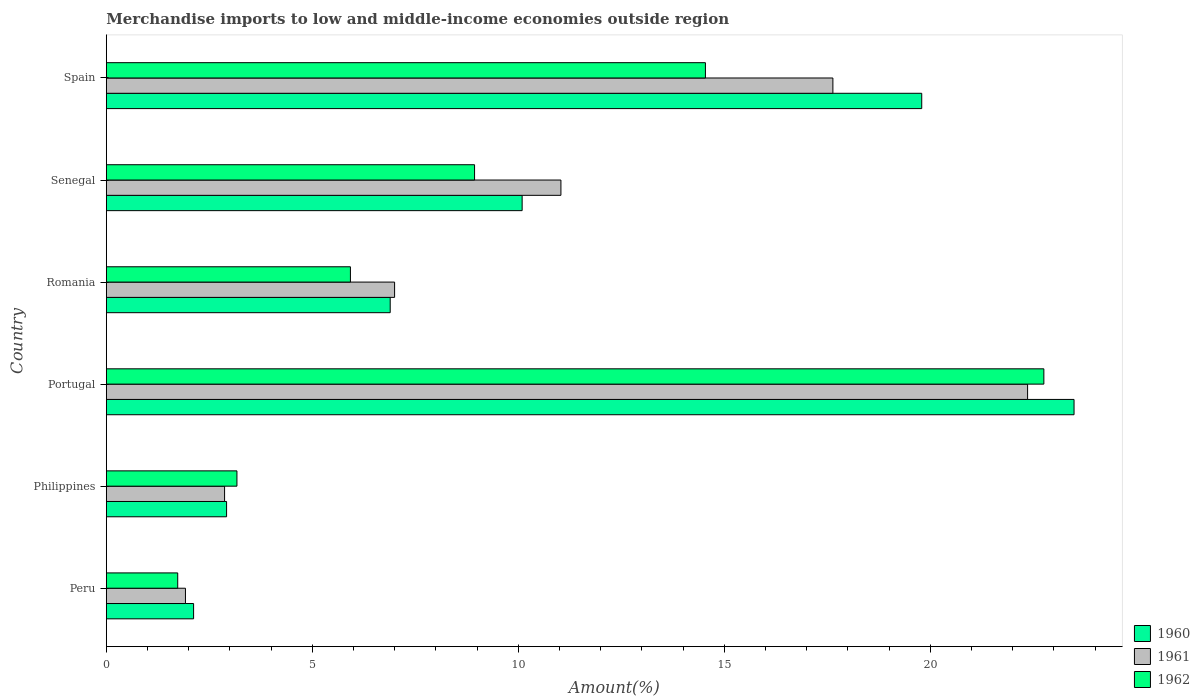How many different coloured bars are there?
Keep it short and to the point. 3. How many groups of bars are there?
Offer a terse response. 6. What is the label of the 3rd group of bars from the top?
Offer a very short reply. Romania. What is the percentage of amount earned from merchandise imports in 1960 in Senegal?
Your response must be concise. 10.09. Across all countries, what is the maximum percentage of amount earned from merchandise imports in 1962?
Provide a short and direct response. 22.76. Across all countries, what is the minimum percentage of amount earned from merchandise imports in 1962?
Offer a very short reply. 1.73. In which country was the percentage of amount earned from merchandise imports in 1960 maximum?
Your answer should be very brief. Portugal. What is the total percentage of amount earned from merchandise imports in 1960 in the graph?
Give a very brief answer. 65.3. What is the difference between the percentage of amount earned from merchandise imports in 1960 in Romania and that in Spain?
Your response must be concise. -12.9. What is the difference between the percentage of amount earned from merchandise imports in 1961 in Spain and the percentage of amount earned from merchandise imports in 1962 in Philippines?
Make the answer very short. 14.47. What is the average percentage of amount earned from merchandise imports in 1961 per country?
Ensure brevity in your answer.  10.47. What is the difference between the percentage of amount earned from merchandise imports in 1962 and percentage of amount earned from merchandise imports in 1960 in Portugal?
Offer a terse response. -0.73. In how many countries, is the percentage of amount earned from merchandise imports in 1960 greater than 16 %?
Your answer should be very brief. 2. What is the ratio of the percentage of amount earned from merchandise imports in 1962 in Peru to that in Portugal?
Provide a succinct answer. 0.08. Is the percentage of amount earned from merchandise imports in 1962 in Philippines less than that in Portugal?
Give a very brief answer. Yes. Is the difference between the percentage of amount earned from merchandise imports in 1962 in Senegal and Spain greater than the difference between the percentage of amount earned from merchandise imports in 1960 in Senegal and Spain?
Offer a terse response. Yes. What is the difference between the highest and the second highest percentage of amount earned from merchandise imports in 1962?
Provide a succinct answer. 8.21. What is the difference between the highest and the lowest percentage of amount earned from merchandise imports in 1960?
Provide a succinct answer. 21.37. Is the sum of the percentage of amount earned from merchandise imports in 1960 in Peru and Spain greater than the maximum percentage of amount earned from merchandise imports in 1962 across all countries?
Provide a short and direct response. No. What does the 1st bar from the top in Spain represents?
Keep it short and to the point. 1962. How many bars are there?
Keep it short and to the point. 18. How many countries are there in the graph?
Ensure brevity in your answer.  6. Does the graph contain any zero values?
Keep it short and to the point. No. Does the graph contain grids?
Ensure brevity in your answer.  No. How are the legend labels stacked?
Provide a succinct answer. Vertical. What is the title of the graph?
Make the answer very short. Merchandise imports to low and middle-income economies outside region. What is the label or title of the X-axis?
Provide a short and direct response. Amount(%). What is the label or title of the Y-axis?
Provide a short and direct response. Country. What is the Amount(%) of 1960 in Peru?
Offer a terse response. 2.12. What is the Amount(%) of 1961 in Peru?
Make the answer very short. 1.92. What is the Amount(%) in 1962 in Peru?
Keep it short and to the point. 1.73. What is the Amount(%) in 1960 in Philippines?
Provide a short and direct response. 2.92. What is the Amount(%) in 1961 in Philippines?
Your response must be concise. 2.87. What is the Amount(%) of 1962 in Philippines?
Provide a succinct answer. 3.17. What is the Amount(%) of 1960 in Portugal?
Offer a very short reply. 23.49. What is the Amount(%) in 1961 in Portugal?
Provide a succinct answer. 22.36. What is the Amount(%) of 1962 in Portugal?
Your answer should be very brief. 22.76. What is the Amount(%) of 1960 in Romania?
Give a very brief answer. 6.89. What is the Amount(%) in 1961 in Romania?
Your answer should be compact. 7. What is the Amount(%) of 1962 in Romania?
Your answer should be very brief. 5.92. What is the Amount(%) of 1960 in Senegal?
Provide a succinct answer. 10.09. What is the Amount(%) of 1961 in Senegal?
Your response must be concise. 11.03. What is the Amount(%) of 1962 in Senegal?
Provide a succinct answer. 8.94. What is the Amount(%) of 1960 in Spain?
Your response must be concise. 19.79. What is the Amount(%) in 1961 in Spain?
Provide a short and direct response. 17.64. What is the Amount(%) of 1962 in Spain?
Keep it short and to the point. 14.54. Across all countries, what is the maximum Amount(%) in 1960?
Ensure brevity in your answer.  23.49. Across all countries, what is the maximum Amount(%) in 1961?
Your answer should be compact. 22.36. Across all countries, what is the maximum Amount(%) in 1962?
Your response must be concise. 22.76. Across all countries, what is the minimum Amount(%) in 1960?
Give a very brief answer. 2.12. Across all countries, what is the minimum Amount(%) of 1961?
Offer a terse response. 1.92. Across all countries, what is the minimum Amount(%) of 1962?
Provide a short and direct response. 1.73. What is the total Amount(%) of 1960 in the graph?
Make the answer very short. 65.3. What is the total Amount(%) in 1961 in the graph?
Offer a very short reply. 62.82. What is the total Amount(%) in 1962 in the graph?
Your response must be concise. 57.06. What is the difference between the Amount(%) of 1960 in Peru and that in Philippines?
Offer a terse response. -0.8. What is the difference between the Amount(%) in 1961 in Peru and that in Philippines?
Your response must be concise. -0.95. What is the difference between the Amount(%) in 1962 in Peru and that in Philippines?
Offer a very short reply. -1.44. What is the difference between the Amount(%) in 1960 in Peru and that in Portugal?
Give a very brief answer. -21.37. What is the difference between the Amount(%) of 1961 in Peru and that in Portugal?
Your answer should be very brief. -20.44. What is the difference between the Amount(%) in 1962 in Peru and that in Portugal?
Give a very brief answer. -21.02. What is the difference between the Amount(%) of 1960 in Peru and that in Romania?
Keep it short and to the point. -4.77. What is the difference between the Amount(%) of 1961 in Peru and that in Romania?
Provide a succinct answer. -5.08. What is the difference between the Amount(%) in 1962 in Peru and that in Romania?
Keep it short and to the point. -4.19. What is the difference between the Amount(%) in 1960 in Peru and that in Senegal?
Keep it short and to the point. -7.97. What is the difference between the Amount(%) of 1961 in Peru and that in Senegal?
Offer a terse response. -9.11. What is the difference between the Amount(%) of 1962 in Peru and that in Senegal?
Your answer should be very brief. -7.21. What is the difference between the Amount(%) of 1960 in Peru and that in Spain?
Your response must be concise. -17.67. What is the difference between the Amount(%) of 1961 in Peru and that in Spain?
Your answer should be compact. -15.71. What is the difference between the Amount(%) in 1962 in Peru and that in Spain?
Your answer should be compact. -12.81. What is the difference between the Amount(%) in 1960 in Philippines and that in Portugal?
Provide a succinct answer. -20.57. What is the difference between the Amount(%) of 1961 in Philippines and that in Portugal?
Your answer should be very brief. -19.49. What is the difference between the Amount(%) in 1962 in Philippines and that in Portugal?
Provide a short and direct response. -19.59. What is the difference between the Amount(%) of 1960 in Philippines and that in Romania?
Give a very brief answer. -3.97. What is the difference between the Amount(%) in 1961 in Philippines and that in Romania?
Your response must be concise. -4.13. What is the difference between the Amount(%) of 1962 in Philippines and that in Romania?
Your answer should be very brief. -2.75. What is the difference between the Amount(%) in 1960 in Philippines and that in Senegal?
Offer a terse response. -7.17. What is the difference between the Amount(%) of 1961 in Philippines and that in Senegal?
Ensure brevity in your answer.  -8.16. What is the difference between the Amount(%) of 1962 in Philippines and that in Senegal?
Your answer should be very brief. -5.77. What is the difference between the Amount(%) of 1960 in Philippines and that in Spain?
Ensure brevity in your answer.  -16.87. What is the difference between the Amount(%) of 1961 in Philippines and that in Spain?
Give a very brief answer. -14.77. What is the difference between the Amount(%) in 1962 in Philippines and that in Spain?
Ensure brevity in your answer.  -11.37. What is the difference between the Amount(%) of 1960 in Portugal and that in Romania?
Your response must be concise. 16.6. What is the difference between the Amount(%) in 1961 in Portugal and that in Romania?
Offer a very short reply. 15.36. What is the difference between the Amount(%) of 1962 in Portugal and that in Romania?
Provide a succinct answer. 16.83. What is the difference between the Amount(%) of 1960 in Portugal and that in Senegal?
Your answer should be very brief. 13.4. What is the difference between the Amount(%) in 1961 in Portugal and that in Senegal?
Make the answer very short. 11.33. What is the difference between the Amount(%) in 1962 in Portugal and that in Senegal?
Your response must be concise. 13.82. What is the difference between the Amount(%) of 1960 in Portugal and that in Spain?
Your answer should be compact. 3.7. What is the difference between the Amount(%) in 1961 in Portugal and that in Spain?
Keep it short and to the point. 4.73. What is the difference between the Amount(%) in 1962 in Portugal and that in Spain?
Your answer should be compact. 8.21. What is the difference between the Amount(%) in 1960 in Romania and that in Senegal?
Ensure brevity in your answer.  -3.2. What is the difference between the Amount(%) in 1961 in Romania and that in Senegal?
Your answer should be very brief. -4.04. What is the difference between the Amount(%) of 1962 in Romania and that in Senegal?
Keep it short and to the point. -3.01. What is the difference between the Amount(%) of 1960 in Romania and that in Spain?
Make the answer very short. -12.9. What is the difference between the Amount(%) of 1961 in Romania and that in Spain?
Make the answer very short. -10.64. What is the difference between the Amount(%) of 1962 in Romania and that in Spain?
Your answer should be very brief. -8.62. What is the difference between the Amount(%) of 1960 in Senegal and that in Spain?
Your response must be concise. -9.7. What is the difference between the Amount(%) in 1961 in Senegal and that in Spain?
Offer a very short reply. -6.6. What is the difference between the Amount(%) of 1962 in Senegal and that in Spain?
Offer a very short reply. -5.6. What is the difference between the Amount(%) in 1960 in Peru and the Amount(%) in 1961 in Philippines?
Ensure brevity in your answer.  -0.75. What is the difference between the Amount(%) of 1960 in Peru and the Amount(%) of 1962 in Philippines?
Provide a succinct answer. -1.05. What is the difference between the Amount(%) of 1961 in Peru and the Amount(%) of 1962 in Philippines?
Keep it short and to the point. -1.25. What is the difference between the Amount(%) of 1960 in Peru and the Amount(%) of 1961 in Portugal?
Offer a terse response. -20.24. What is the difference between the Amount(%) of 1960 in Peru and the Amount(%) of 1962 in Portugal?
Provide a short and direct response. -20.64. What is the difference between the Amount(%) of 1961 in Peru and the Amount(%) of 1962 in Portugal?
Offer a very short reply. -20.84. What is the difference between the Amount(%) of 1960 in Peru and the Amount(%) of 1961 in Romania?
Ensure brevity in your answer.  -4.88. What is the difference between the Amount(%) of 1960 in Peru and the Amount(%) of 1962 in Romania?
Make the answer very short. -3.81. What is the difference between the Amount(%) of 1961 in Peru and the Amount(%) of 1962 in Romania?
Provide a short and direct response. -4. What is the difference between the Amount(%) of 1960 in Peru and the Amount(%) of 1961 in Senegal?
Give a very brief answer. -8.92. What is the difference between the Amount(%) in 1960 in Peru and the Amount(%) in 1962 in Senegal?
Your answer should be compact. -6.82. What is the difference between the Amount(%) of 1961 in Peru and the Amount(%) of 1962 in Senegal?
Give a very brief answer. -7.02. What is the difference between the Amount(%) in 1960 in Peru and the Amount(%) in 1961 in Spain?
Keep it short and to the point. -15.52. What is the difference between the Amount(%) of 1960 in Peru and the Amount(%) of 1962 in Spain?
Your answer should be very brief. -12.42. What is the difference between the Amount(%) of 1961 in Peru and the Amount(%) of 1962 in Spain?
Keep it short and to the point. -12.62. What is the difference between the Amount(%) of 1960 in Philippines and the Amount(%) of 1961 in Portugal?
Your answer should be compact. -19.44. What is the difference between the Amount(%) of 1960 in Philippines and the Amount(%) of 1962 in Portugal?
Give a very brief answer. -19.84. What is the difference between the Amount(%) in 1961 in Philippines and the Amount(%) in 1962 in Portugal?
Your answer should be very brief. -19.89. What is the difference between the Amount(%) of 1960 in Philippines and the Amount(%) of 1961 in Romania?
Keep it short and to the point. -4.08. What is the difference between the Amount(%) in 1960 in Philippines and the Amount(%) in 1962 in Romania?
Offer a very short reply. -3.01. What is the difference between the Amount(%) in 1961 in Philippines and the Amount(%) in 1962 in Romania?
Keep it short and to the point. -3.05. What is the difference between the Amount(%) of 1960 in Philippines and the Amount(%) of 1961 in Senegal?
Keep it short and to the point. -8.12. What is the difference between the Amount(%) in 1960 in Philippines and the Amount(%) in 1962 in Senegal?
Your answer should be compact. -6.02. What is the difference between the Amount(%) of 1961 in Philippines and the Amount(%) of 1962 in Senegal?
Make the answer very short. -6.07. What is the difference between the Amount(%) of 1960 in Philippines and the Amount(%) of 1961 in Spain?
Your answer should be very brief. -14.72. What is the difference between the Amount(%) of 1960 in Philippines and the Amount(%) of 1962 in Spain?
Make the answer very short. -11.62. What is the difference between the Amount(%) of 1961 in Philippines and the Amount(%) of 1962 in Spain?
Offer a terse response. -11.67. What is the difference between the Amount(%) of 1960 in Portugal and the Amount(%) of 1961 in Romania?
Ensure brevity in your answer.  16.49. What is the difference between the Amount(%) in 1960 in Portugal and the Amount(%) in 1962 in Romania?
Your response must be concise. 17.56. What is the difference between the Amount(%) in 1961 in Portugal and the Amount(%) in 1962 in Romania?
Give a very brief answer. 16.44. What is the difference between the Amount(%) of 1960 in Portugal and the Amount(%) of 1961 in Senegal?
Your response must be concise. 12.45. What is the difference between the Amount(%) of 1960 in Portugal and the Amount(%) of 1962 in Senegal?
Keep it short and to the point. 14.55. What is the difference between the Amount(%) of 1961 in Portugal and the Amount(%) of 1962 in Senegal?
Provide a succinct answer. 13.42. What is the difference between the Amount(%) in 1960 in Portugal and the Amount(%) in 1961 in Spain?
Your response must be concise. 5.85. What is the difference between the Amount(%) in 1960 in Portugal and the Amount(%) in 1962 in Spain?
Your response must be concise. 8.95. What is the difference between the Amount(%) in 1961 in Portugal and the Amount(%) in 1962 in Spain?
Ensure brevity in your answer.  7.82. What is the difference between the Amount(%) in 1960 in Romania and the Amount(%) in 1961 in Senegal?
Give a very brief answer. -4.14. What is the difference between the Amount(%) in 1960 in Romania and the Amount(%) in 1962 in Senegal?
Provide a succinct answer. -2.05. What is the difference between the Amount(%) of 1961 in Romania and the Amount(%) of 1962 in Senegal?
Give a very brief answer. -1.94. What is the difference between the Amount(%) of 1960 in Romania and the Amount(%) of 1961 in Spain?
Your answer should be very brief. -10.75. What is the difference between the Amount(%) of 1960 in Romania and the Amount(%) of 1962 in Spain?
Keep it short and to the point. -7.65. What is the difference between the Amount(%) of 1961 in Romania and the Amount(%) of 1962 in Spain?
Your answer should be compact. -7.54. What is the difference between the Amount(%) in 1960 in Senegal and the Amount(%) in 1961 in Spain?
Provide a succinct answer. -7.54. What is the difference between the Amount(%) of 1960 in Senegal and the Amount(%) of 1962 in Spain?
Your response must be concise. -4.45. What is the difference between the Amount(%) in 1961 in Senegal and the Amount(%) in 1962 in Spain?
Your answer should be very brief. -3.51. What is the average Amount(%) in 1960 per country?
Give a very brief answer. 10.88. What is the average Amount(%) of 1961 per country?
Make the answer very short. 10.47. What is the average Amount(%) in 1962 per country?
Your answer should be compact. 9.51. What is the difference between the Amount(%) of 1960 and Amount(%) of 1961 in Peru?
Your answer should be compact. 0.2. What is the difference between the Amount(%) in 1960 and Amount(%) in 1962 in Peru?
Keep it short and to the point. 0.39. What is the difference between the Amount(%) of 1961 and Amount(%) of 1962 in Peru?
Your answer should be very brief. 0.19. What is the difference between the Amount(%) in 1960 and Amount(%) in 1961 in Philippines?
Provide a short and direct response. 0.05. What is the difference between the Amount(%) in 1960 and Amount(%) in 1962 in Philippines?
Give a very brief answer. -0.25. What is the difference between the Amount(%) in 1961 and Amount(%) in 1962 in Philippines?
Your answer should be very brief. -0.3. What is the difference between the Amount(%) in 1960 and Amount(%) in 1961 in Portugal?
Ensure brevity in your answer.  1.13. What is the difference between the Amount(%) in 1960 and Amount(%) in 1962 in Portugal?
Provide a succinct answer. 0.73. What is the difference between the Amount(%) of 1961 and Amount(%) of 1962 in Portugal?
Your answer should be very brief. -0.39. What is the difference between the Amount(%) in 1960 and Amount(%) in 1961 in Romania?
Your response must be concise. -0.11. What is the difference between the Amount(%) of 1960 and Amount(%) of 1962 in Romania?
Offer a terse response. 0.97. What is the difference between the Amount(%) in 1961 and Amount(%) in 1962 in Romania?
Provide a succinct answer. 1.07. What is the difference between the Amount(%) in 1960 and Amount(%) in 1961 in Senegal?
Your answer should be compact. -0.94. What is the difference between the Amount(%) in 1960 and Amount(%) in 1962 in Senegal?
Make the answer very short. 1.16. What is the difference between the Amount(%) in 1961 and Amount(%) in 1962 in Senegal?
Your answer should be compact. 2.1. What is the difference between the Amount(%) of 1960 and Amount(%) of 1961 in Spain?
Ensure brevity in your answer.  2.16. What is the difference between the Amount(%) in 1960 and Amount(%) in 1962 in Spain?
Give a very brief answer. 5.25. What is the difference between the Amount(%) of 1961 and Amount(%) of 1962 in Spain?
Your answer should be very brief. 3.09. What is the ratio of the Amount(%) of 1960 in Peru to that in Philippines?
Keep it short and to the point. 0.73. What is the ratio of the Amount(%) of 1961 in Peru to that in Philippines?
Ensure brevity in your answer.  0.67. What is the ratio of the Amount(%) in 1962 in Peru to that in Philippines?
Your answer should be compact. 0.55. What is the ratio of the Amount(%) of 1960 in Peru to that in Portugal?
Offer a terse response. 0.09. What is the ratio of the Amount(%) of 1961 in Peru to that in Portugal?
Your response must be concise. 0.09. What is the ratio of the Amount(%) of 1962 in Peru to that in Portugal?
Ensure brevity in your answer.  0.08. What is the ratio of the Amount(%) of 1960 in Peru to that in Romania?
Your response must be concise. 0.31. What is the ratio of the Amount(%) in 1961 in Peru to that in Romania?
Make the answer very short. 0.27. What is the ratio of the Amount(%) of 1962 in Peru to that in Romania?
Make the answer very short. 0.29. What is the ratio of the Amount(%) in 1960 in Peru to that in Senegal?
Provide a succinct answer. 0.21. What is the ratio of the Amount(%) in 1961 in Peru to that in Senegal?
Your response must be concise. 0.17. What is the ratio of the Amount(%) of 1962 in Peru to that in Senegal?
Give a very brief answer. 0.19. What is the ratio of the Amount(%) in 1960 in Peru to that in Spain?
Make the answer very short. 0.11. What is the ratio of the Amount(%) of 1961 in Peru to that in Spain?
Offer a terse response. 0.11. What is the ratio of the Amount(%) of 1962 in Peru to that in Spain?
Ensure brevity in your answer.  0.12. What is the ratio of the Amount(%) of 1960 in Philippines to that in Portugal?
Keep it short and to the point. 0.12. What is the ratio of the Amount(%) of 1961 in Philippines to that in Portugal?
Give a very brief answer. 0.13. What is the ratio of the Amount(%) in 1962 in Philippines to that in Portugal?
Ensure brevity in your answer.  0.14. What is the ratio of the Amount(%) of 1960 in Philippines to that in Romania?
Ensure brevity in your answer.  0.42. What is the ratio of the Amount(%) in 1961 in Philippines to that in Romania?
Your answer should be very brief. 0.41. What is the ratio of the Amount(%) of 1962 in Philippines to that in Romania?
Your answer should be very brief. 0.54. What is the ratio of the Amount(%) of 1960 in Philippines to that in Senegal?
Your response must be concise. 0.29. What is the ratio of the Amount(%) of 1961 in Philippines to that in Senegal?
Offer a terse response. 0.26. What is the ratio of the Amount(%) in 1962 in Philippines to that in Senegal?
Keep it short and to the point. 0.35. What is the ratio of the Amount(%) of 1960 in Philippines to that in Spain?
Offer a terse response. 0.15. What is the ratio of the Amount(%) of 1961 in Philippines to that in Spain?
Give a very brief answer. 0.16. What is the ratio of the Amount(%) in 1962 in Philippines to that in Spain?
Provide a short and direct response. 0.22. What is the ratio of the Amount(%) in 1960 in Portugal to that in Romania?
Offer a terse response. 3.41. What is the ratio of the Amount(%) of 1961 in Portugal to that in Romania?
Keep it short and to the point. 3.2. What is the ratio of the Amount(%) in 1962 in Portugal to that in Romania?
Keep it short and to the point. 3.84. What is the ratio of the Amount(%) in 1960 in Portugal to that in Senegal?
Make the answer very short. 2.33. What is the ratio of the Amount(%) of 1961 in Portugal to that in Senegal?
Your answer should be very brief. 2.03. What is the ratio of the Amount(%) of 1962 in Portugal to that in Senegal?
Give a very brief answer. 2.55. What is the ratio of the Amount(%) of 1960 in Portugal to that in Spain?
Provide a short and direct response. 1.19. What is the ratio of the Amount(%) of 1961 in Portugal to that in Spain?
Your response must be concise. 1.27. What is the ratio of the Amount(%) of 1962 in Portugal to that in Spain?
Your answer should be very brief. 1.56. What is the ratio of the Amount(%) of 1960 in Romania to that in Senegal?
Make the answer very short. 0.68. What is the ratio of the Amount(%) in 1961 in Romania to that in Senegal?
Offer a very short reply. 0.63. What is the ratio of the Amount(%) of 1962 in Romania to that in Senegal?
Offer a terse response. 0.66. What is the ratio of the Amount(%) of 1960 in Romania to that in Spain?
Ensure brevity in your answer.  0.35. What is the ratio of the Amount(%) in 1961 in Romania to that in Spain?
Give a very brief answer. 0.4. What is the ratio of the Amount(%) of 1962 in Romania to that in Spain?
Your answer should be compact. 0.41. What is the ratio of the Amount(%) of 1960 in Senegal to that in Spain?
Give a very brief answer. 0.51. What is the ratio of the Amount(%) in 1961 in Senegal to that in Spain?
Your response must be concise. 0.63. What is the ratio of the Amount(%) of 1962 in Senegal to that in Spain?
Provide a short and direct response. 0.61. What is the difference between the highest and the second highest Amount(%) of 1960?
Provide a short and direct response. 3.7. What is the difference between the highest and the second highest Amount(%) of 1961?
Your answer should be very brief. 4.73. What is the difference between the highest and the second highest Amount(%) in 1962?
Keep it short and to the point. 8.21. What is the difference between the highest and the lowest Amount(%) of 1960?
Your response must be concise. 21.37. What is the difference between the highest and the lowest Amount(%) of 1961?
Your answer should be very brief. 20.44. What is the difference between the highest and the lowest Amount(%) of 1962?
Your answer should be compact. 21.02. 